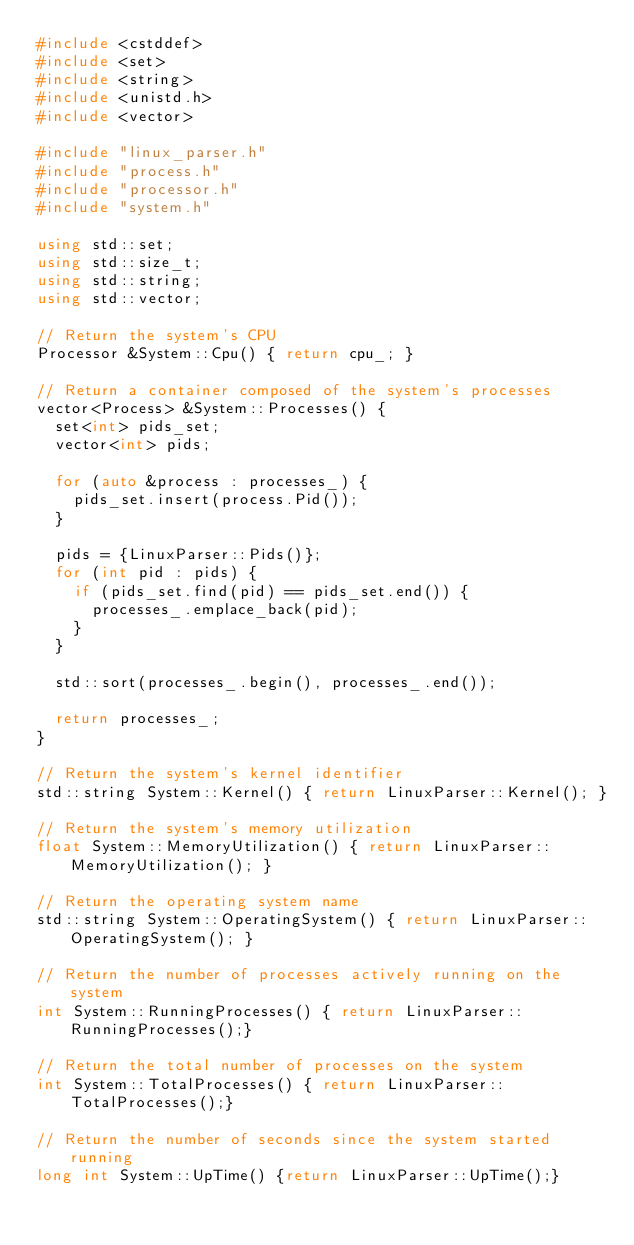Convert code to text. <code><loc_0><loc_0><loc_500><loc_500><_C++_>#include <cstddef>
#include <set>
#include <string>
#include <unistd.h>
#include <vector>

#include "linux_parser.h"
#include "process.h"
#include "processor.h"
#include "system.h"

using std::set;
using std::size_t;
using std::string;
using std::vector;

// Return the system's CPU
Processor &System::Cpu() { return cpu_; }

// Return a container composed of the system's processes
vector<Process> &System::Processes() {
  set<int> pids_set;
  vector<int> pids;

  for (auto &process : processes_) {
    pids_set.insert(process.Pid());
  }

  pids = {LinuxParser::Pids()};
  for (int pid : pids) {
    if (pids_set.find(pid) == pids_set.end()) {
      processes_.emplace_back(pid);
    }
  }

  std::sort(processes_.begin(), processes_.end());

  return processes_;
}

// Return the system's kernel identifier
std::string System::Kernel() { return LinuxParser::Kernel(); }

// Return the system's memory utilization
float System::MemoryUtilization() { return LinuxParser::MemoryUtilization(); }

// Return the operating system name
std::string System::OperatingSystem() { return LinuxParser::OperatingSystem(); }

// Return the number of processes actively running on the system
int System::RunningProcesses() { return LinuxParser::RunningProcesses();}

// Return the total number of processes on the system
int System::TotalProcesses() { return LinuxParser::TotalProcesses();}

// Return the number of seconds since the system started running
long int System::UpTime() {return LinuxParser::UpTime();}</code> 